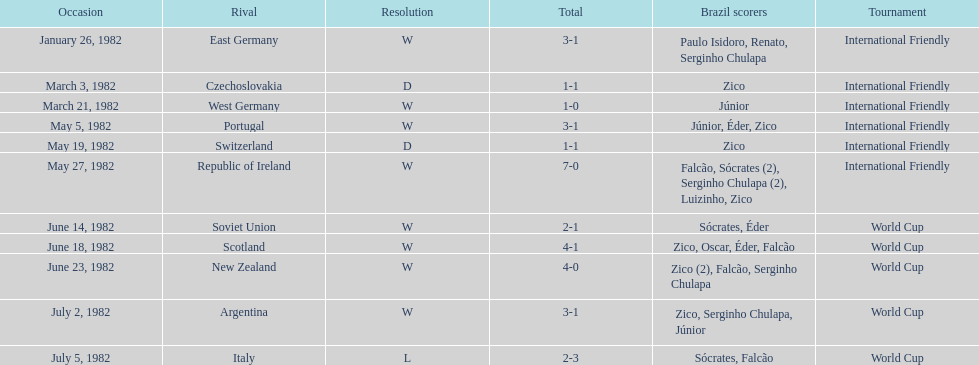What was the total number of losses brazil suffered? 1. 